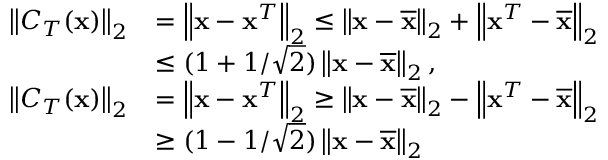Convert formula to latex. <formula><loc_0><loc_0><loc_500><loc_500>\begin{array} { r l } { \left \| C _ { T } ( { x } ) \right \| _ { 2 } } & { = \left \| { x } - { x } ^ { T } \right \| _ { 2 } \leq \left \| { x } - \overline { x } \right \| _ { 2 } + \left \| { x } ^ { T } - \overline { x } \right \| _ { 2 } } \\ & { \leq ( 1 + 1 / \sqrt { 2 } ) \left \| { x } - \overline { x } \right \| _ { 2 } , } \\ { \left \| C _ { T } ( { x } ) \right \| _ { 2 } } & { = \left \| { x } - { x } ^ { T } \right \| _ { 2 } \geq \left \| { x } - \overline { x } \right \| _ { 2 } - \left \| { x } ^ { T } - \overline { x } \right \| _ { 2 } } \\ & { \geq ( 1 - 1 / \sqrt { 2 } ) \left \| { x } - \overline { x } \right \| _ { 2 } } \end{array}</formula> 